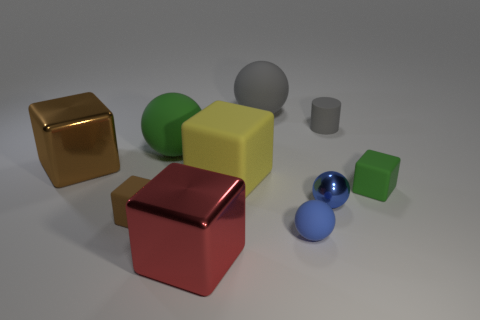What number of yellow blocks are there?
Your answer should be very brief. 1. What shape is the tiny brown thing on the left side of the red thing?
Make the answer very short. Cube. What number of other objects are there of the same size as the gray rubber cylinder?
Provide a succinct answer. 4. Do the gray object on the right side of the tiny blue rubber ball and the small matte thing that is left of the yellow thing have the same shape?
Ensure brevity in your answer.  No. There is a metallic sphere; how many small green matte blocks are in front of it?
Provide a short and direct response. 0. There is a metal thing that is right of the yellow cube; what color is it?
Keep it short and to the point. Blue. There is another tiny thing that is the same shape as the small blue rubber object; what color is it?
Provide a succinct answer. Blue. Is there anything else of the same color as the rubber cylinder?
Give a very brief answer. Yes. Are there more tiny metal objects than large matte things?
Offer a very short reply. No. Is the material of the large green object the same as the big yellow cube?
Provide a succinct answer. Yes. 